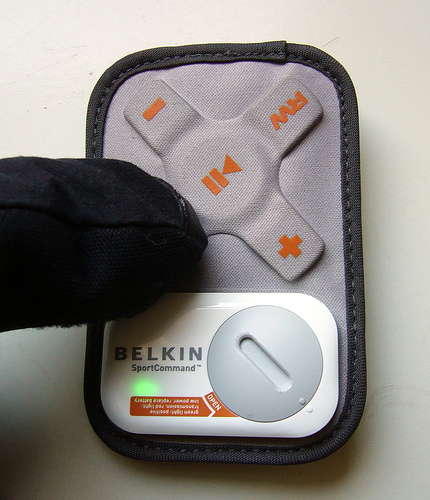<image>
Can you confirm if the remote is behind the finger? Yes. From this viewpoint, the remote is positioned behind the finger, with the finger partially or fully occluding the remote. 